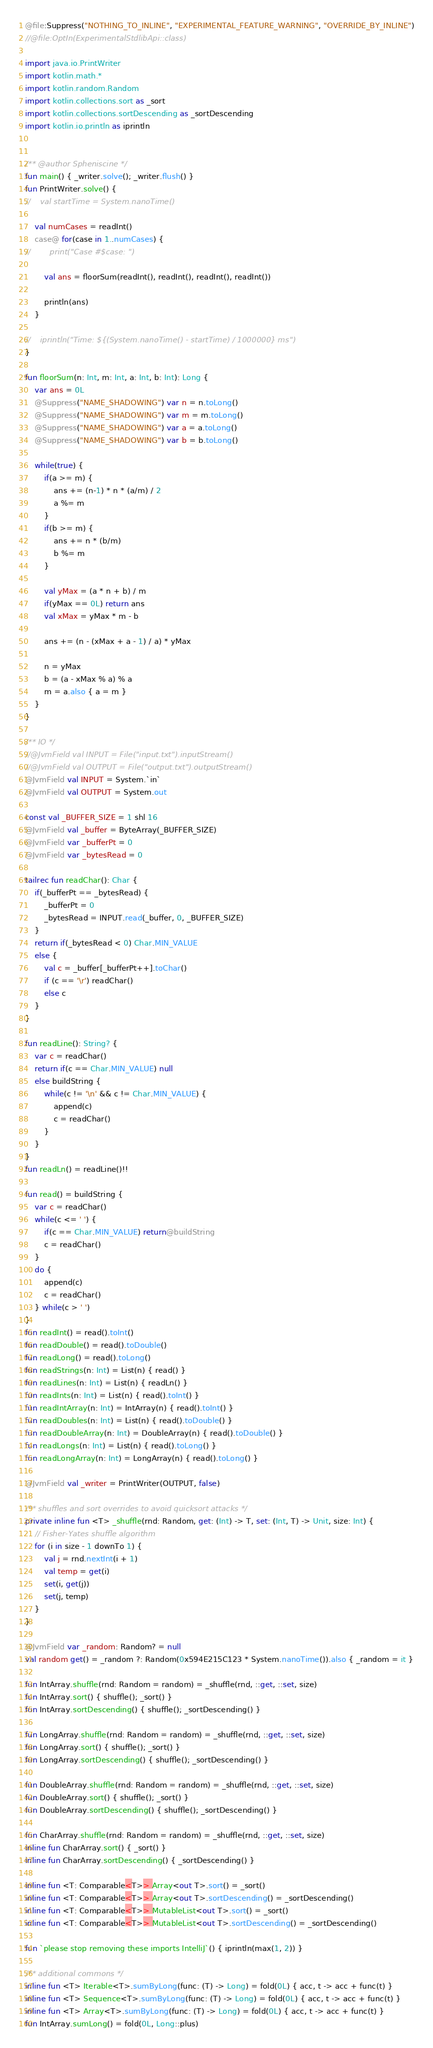<code> <loc_0><loc_0><loc_500><loc_500><_Kotlin_>@file:Suppress("NOTHING_TO_INLINE", "EXPERIMENTAL_FEATURE_WARNING", "OVERRIDE_BY_INLINE")
//@file:OptIn(ExperimentalStdlibApi::class)

import java.io.PrintWriter
import kotlin.math.*
import kotlin.random.Random
import kotlin.collections.sort as _sort
import kotlin.collections.sortDescending as _sortDescending
import kotlin.io.println as iprintln


/** @author Spheniscine */
fun main() { _writer.solve(); _writer.flush() }
fun PrintWriter.solve() {
//    val startTime = System.nanoTime()

    val numCases = readInt()
    case@ for(case in 1..numCases) {
//        print("Case #$case: ")

        val ans = floorSum(readInt(), readInt(), readInt(), readInt())

        println(ans)
    }

//    iprintln("Time: ${(System.nanoTime() - startTime) / 1000000} ms")
}

fun floorSum(n: Int, m: Int, a: Int, b: Int): Long {
    var ans = 0L
    @Suppress("NAME_SHADOWING") var n = n.toLong()
    @Suppress("NAME_SHADOWING") var m = m.toLong()
    @Suppress("NAME_SHADOWING") var a = a.toLong()
    @Suppress("NAME_SHADOWING") var b = b.toLong()

    while(true) {
        if(a >= m) {
            ans += (n-1) * n * (a/m) / 2
            a %= m
        }
        if(b >= m) {
            ans += n * (b/m)
            b %= m
        }

        val yMax = (a * n + b) / m
        if(yMax == 0L) return ans
        val xMax = yMax * m - b

        ans += (n - (xMax + a - 1) / a) * yMax

        n = yMax
        b = (a - xMax % a) % a
        m = a.also { a = m }
    }
}

/** IO */
//@JvmField val INPUT = File("input.txt").inputStream()
//@JvmField val OUTPUT = File("output.txt").outputStream()
@JvmField val INPUT = System.`in`
@JvmField val OUTPUT = System.out

const val _BUFFER_SIZE = 1 shl 16
@JvmField val _buffer = ByteArray(_BUFFER_SIZE)
@JvmField var _bufferPt = 0
@JvmField var _bytesRead = 0

tailrec fun readChar(): Char {
    if(_bufferPt == _bytesRead) {
        _bufferPt = 0
        _bytesRead = INPUT.read(_buffer, 0, _BUFFER_SIZE)
    }
    return if(_bytesRead < 0) Char.MIN_VALUE
    else {
        val c = _buffer[_bufferPt++].toChar()
        if (c == '\r') readChar()
        else c
    }
}

fun readLine(): String? {
    var c = readChar()
    return if(c == Char.MIN_VALUE) null
    else buildString {
        while(c != '\n' && c != Char.MIN_VALUE) {
            append(c)
            c = readChar()
        }
    }
}
fun readLn() = readLine()!!

fun read() = buildString {
    var c = readChar()
    while(c <= ' ') {
        if(c == Char.MIN_VALUE) return@buildString
        c = readChar()
    }
    do {
        append(c)
        c = readChar()
    } while(c > ' ')
}
fun readInt() = read().toInt()
fun readDouble() = read().toDouble()
fun readLong() = read().toLong()
fun readStrings(n: Int) = List(n) { read() }
fun readLines(n: Int) = List(n) { readLn() }
fun readInts(n: Int) = List(n) { read().toInt() }
fun readIntArray(n: Int) = IntArray(n) { read().toInt() }
fun readDoubles(n: Int) = List(n) { read().toDouble() }
fun readDoubleArray(n: Int) = DoubleArray(n) { read().toDouble() }
fun readLongs(n: Int) = List(n) { read().toLong() }
fun readLongArray(n: Int) = LongArray(n) { read().toLong() }

@JvmField val _writer = PrintWriter(OUTPUT, false)

/** shuffles and sort overrides to avoid quicksort attacks */
private inline fun <T> _shuffle(rnd: Random, get: (Int) -> T, set: (Int, T) -> Unit, size: Int) {
    // Fisher-Yates shuffle algorithm
    for (i in size - 1 downTo 1) {
        val j = rnd.nextInt(i + 1)
        val temp = get(i)
        set(i, get(j))
        set(j, temp)
    }
}

@JvmField var _random: Random? = null
val random get() = _random ?: Random(0x594E215C123 * System.nanoTime()).also { _random = it }

fun IntArray.shuffle(rnd: Random = random) = _shuffle(rnd, ::get, ::set, size)
fun IntArray.sort() { shuffle(); _sort() }
fun IntArray.sortDescending() { shuffle(); _sortDescending() }

fun LongArray.shuffle(rnd: Random = random) = _shuffle(rnd, ::get, ::set, size)
fun LongArray.sort() { shuffle(); _sort() }
fun LongArray.sortDescending() { shuffle(); _sortDescending() }

fun DoubleArray.shuffle(rnd: Random = random) = _shuffle(rnd, ::get, ::set, size)
fun DoubleArray.sort() { shuffle(); _sort() }
fun DoubleArray.sortDescending() { shuffle(); _sortDescending() }

fun CharArray.shuffle(rnd: Random = random) = _shuffle(rnd, ::get, ::set, size)
inline fun CharArray.sort() { _sort() }
inline fun CharArray.sortDescending() { _sortDescending() }

inline fun <T: Comparable<T>> Array<out T>.sort() = _sort()
inline fun <T: Comparable<T>> Array<out T>.sortDescending() = _sortDescending()
inline fun <T: Comparable<T>> MutableList<out T>.sort() = _sort()
inline fun <T: Comparable<T>> MutableList<out T>.sortDescending() = _sortDescending()

fun `please stop removing these imports IntelliJ`() { iprintln(max(1, 2)) }

/** additional commons */
inline fun <T> Iterable<T>.sumByLong(func: (T) -> Long) = fold(0L) { acc, t -> acc + func(t) }
inline fun <T> Sequence<T>.sumByLong(func: (T) -> Long) = fold(0L) { acc, t -> acc + func(t) }
inline fun <T> Array<T>.sumByLong(func: (T) -> Long) = fold(0L) { acc, t -> acc + func(t) }
fun IntArray.sumLong() = fold(0L, Long::plus)
</code> 